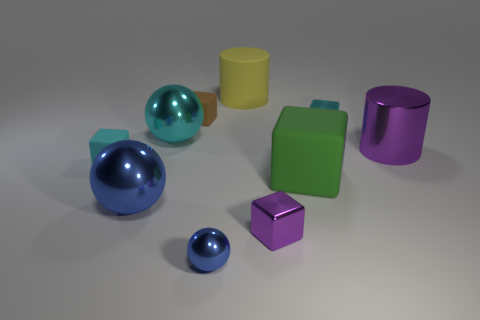Subtract all purple shiny cubes. How many cubes are left? 4 Subtract all yellow cylinders. How many cylinders are left? 1 Subtract all balls. How many objects are left? 7 Subtract 2 cylinders. How many cylinders are left? 0 Subtract all blue cylinders. Subtract all cyan balls. How many cylinders are left? 2 Subtract all yellow spheres. How many cyan cylinders are left? 0 Subtract all big cubes. Subtract all large red shiny cubes. How many objects are left? 9 Add 9 small cyan rubber blocks. How many small cyan rubber blocks are left? 10 Add 3 large brown rubber blocks. How many large brown rubber blocks exist? 3 Subtract 0 purple balls. How many objects are left? 10 